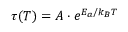Convert formula to latex. <formula><loc_0><loc_0><loc_500><loc_500>\tau ( T ) = A \cdot e ^ { E _ { a } / k _ { B } T }</formula> 